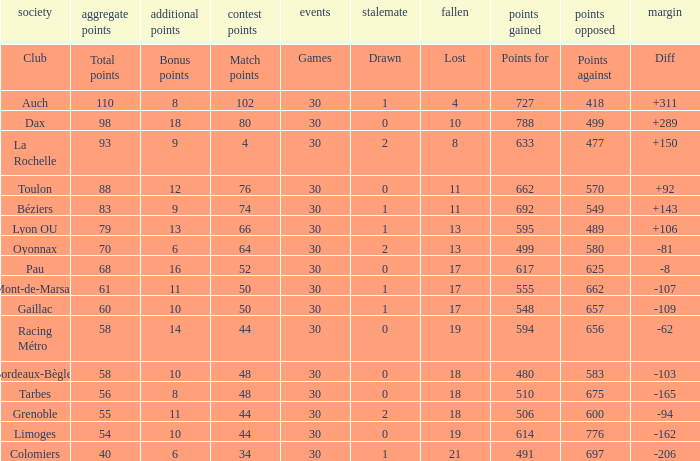What is the value of match points when the points for is 570? 76.0. Help me parse the entirety of this table. {'header': ['society', 'aggregate points', 'additional points', 'contest points', 'events', 'stalemate', 'fallen', 'points gained', 'points opposed', 'margin'], 'rows': [['Club', 'Total points', 'Bonus points', 'Match points', 'Games', 'Drawn', 'Lost', 'Points for', 'Points against', 'Diff'], ['Auch', '110', '8', '102', '30', '1', '4', '727', '418', '+311'], ['Dax', '98', '18', '80', '30', '0', '10', '788', '499', '+289'], ['La Rochelle', '93', '9', '4', '30', '2', '8', '633', '477', '+150'], ['Toulon', '88', '12', '76', '30', '0', '11', '662', '570', '+92'], ['Béziers', '83', '9', '74', '30', '1', '11', '692', '549', '+143'], ['Lyon OU', '79', '13', '66', '30', '1', '13', '595', '489', '+106'], ['Oyonnax', '70', '6', '64', '30', '2', '13', '499', '580', '-81'], ['Pau', '68', '16', '52', '30', '0', '17', '617', '625', '-8'], ['Mont-de-Marsan', '61', '11', '50', '30', '1', '17', '555', '662', '-107'], ['Gaillac', '60', '10', '50', '30', '1', '17', '548', '657', '-109'], ['Racing Métro', '58', '14', '44', '30', '0', '19', '594', '656', '-62'], ['Bordeaux-Bègles', '58', '10', '48', '30', '0', '18', '480', '583', '-103'], ['Tarbes', '56', '8', '48', '30', '0', '18', '510', '675', '-165'], ['Grenoble', '55', '11', '44', '30', '2', '18', '506', '600', '-94'], ['Limoges', '54', '10', '44', '30', '0', '19', '614', '776', '-162'], ['Colomiers', '40', '6', '34', '30', '1', '21', '491', '697', '-206']]} 